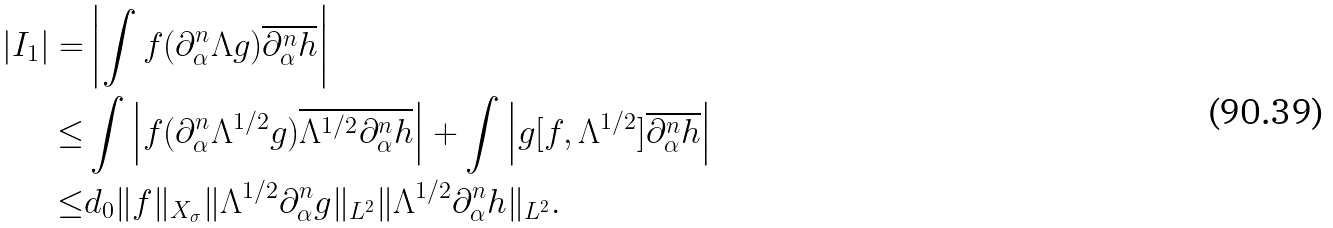Convert formula to latex. <formula><loc_0><loc_0><loc_500><loc_500>| I _ { 1 } | = & \left | \int f ( \partial _ { \alpha } ^ { n } \Lambda g ) \overline { \partial _ { \alpha } ^ { n } h } \right | \\ \leq & \int \left | f ( \partial _ { \alpha } ^ { n } \Lambda ^ { 1 / 2 } g ) \overline { \Lambda ^ { 1 / 2 } \partial _ { \alpha } ^ { n } h } \right | + \int \left | g [ f , \Lambda ^ { 1 / 2 } ] \overline { \partial _ { \alpha } ^ { n } h } \right | \\ \leq & d _ { 0 } \| f \| _ { X _ { \sigma } } \| \Lambda ^ { 1 / 2 } \partial _ { \alpha } ^ { n } g \| _ { L ^ { 2 } } \| \Lambda ^ { 1 / 2 } \partial _ { \alpha } ^ { n } h \| _ { L ^ { 2 } } .</formula> 